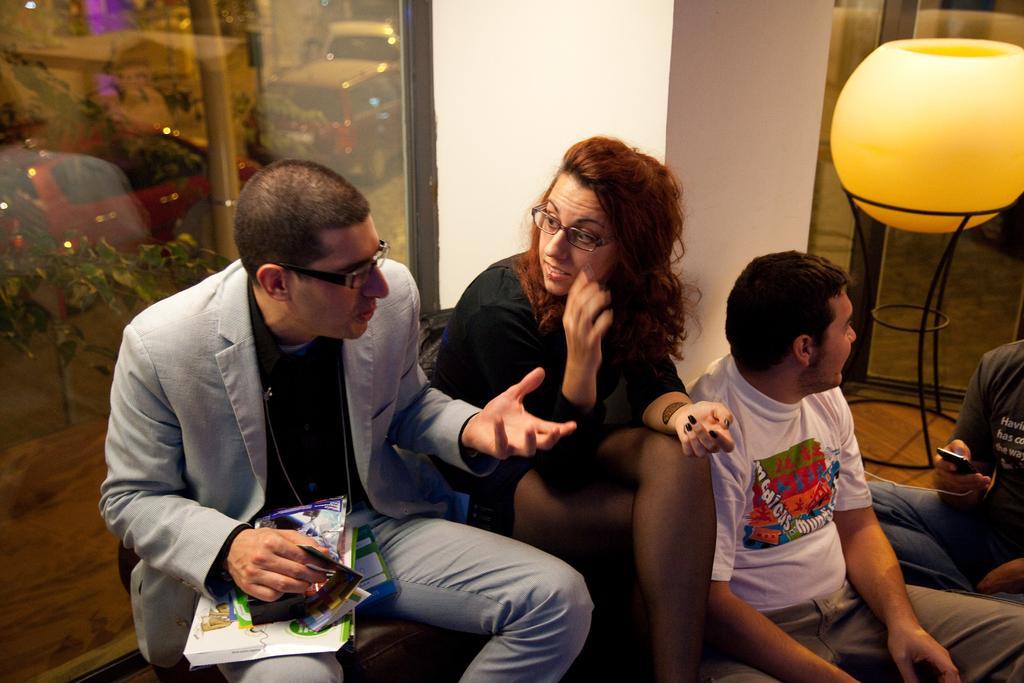Could you give a brief overview of what you see in this image? In this image I can see in the middle a woman and a man are sitting and talking each other, on the right side two persons are sitting on the floor and there is a light. On the left side there is a glass wall, outside this wall there are vehicles on the road. 